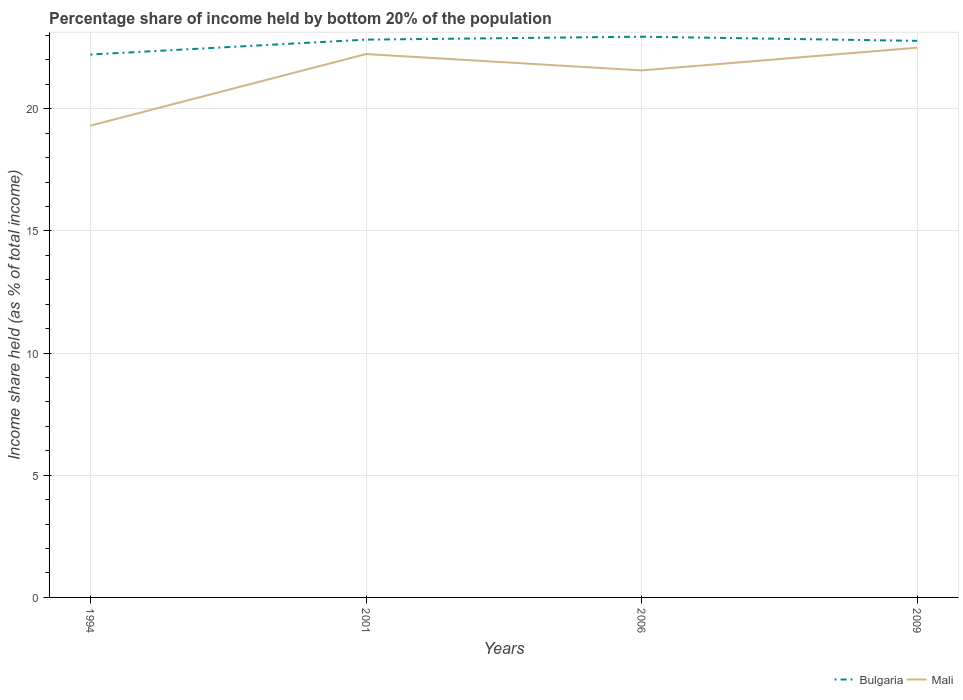How many different coloured lines are there?
Make the answer very short. 2. Does the line corresponding to Mali intersect with the line corresponding to Bulgaria?
Keep it short and to the point. No. Is the number of lines equal to the number of legend labels?
Provide a short and direct response. Yes. Across all years, what is the maximum share of income held by bottom 20% of the population in Bulgaria?
Your answer should be compact. 22.22. In which year was the share of income held by bottom 20% of the population in Bulgaria maximum?
Offer a very short reply. 1994. What is the total share of income held by bottom 20% of the population in Mali in the graph?
Your response must be concise. -3.19. What is the difference between the highest and the second highest share of income held by bottom 20% of the population in Mali?
Make the answer very short. 3.19. What is the difference between the highest and the lowest share of income held by bottom 20% of the population in Mali?
Keep it short and to the point. 3. Is the share of income held by bottom 20% of the population in Bulgaria strictly greater than the share of income held by bottom 20% of the population in Mali over the years?
Make the answer very short. No. How many lines are there?
Give a very brief answer. 2. Are the values on the major ticks of Y-axis written in scientific E-notation?
Offer a very short reply. No. Does the graph contain any zero values?
Your answer should be compact. No. Does the graph contain grids?
Offer a very short reply. Yes. How many legend labels are there?
Provide a succinct answer. 2. What is the title of the graph?
Make the answer very short. Percentage share of income held by bottom 20% of the population. What is the label or title of the X-axis?
Give a very brief answer. Years. What is the label or title of the Y-axis?
Your response must be concise. Income share held (as % of total income). What is the Income share held (as % of total income) of Bulgaria in 1994?
Your answer should be very brief. 22.22. What is the Income share held (as % of total income) in Mali in 1994?
Keep it short and to the point. 19.31. What is the Income share held (as % of total income) in Bulgaria in 2001?
Offer a very short reply. 22.83. What is the Income share held (as % of total income) of Mali in 2001?
Keep it short and to the point. 22.24. What is the Income share held (as % of total income) of Bulgaria in 2006?
Provide a short and direct response. 22.95. What is the Income share held (as % of total income) of Mali in 2006?
Offer a terse response. 21.57. What is the Income share held (as % of total income) of Bulgaria in 2009?
Give a very brief answer. 22.78. Across all years, what is the maximum Income share held (as % of total income) of Bulgaria?
Provide a succinct answer. 22.95. Across all years, what is the minimum Income share held (as % of total income) of Bulgaria?
Keep it short and to the point. 22.22. Across all years, what is the minimum Income share held (as % of total income) of Mali?
Give a very brief answer. 19.31. What is the total Income share held (as % of total income) of Bulgaria in the graph?
Ensure brevity in your answer.  90.78. What is the total Income share held (as % of total income) of Mali in the graph?
Your answer should be very brief. 85.62. What is the difference between the Income share held (as % of total income) in Bulgaria in 1994 and that in 2001?
Ensure brevity in your answer.  -0.61. What is the difference between the Income share held (as % of total income) of Mali in 1994 and that in 2001?
Your answer should be compact. -2.93. What is the difference between the Income share held (as % of total income) in Bulgaria in 1994 and that in 2006?
Offer a terse response. -0.73. What is the difference between the Income share held (as % of total income) of Mali in 1994 and that in 2006?
Your answer should be very brief. -2.26. What is the difference between the Income share held (as % of total income) of Bulgaria in 1994 and that in 2009?
Make the answer very short. -0.56. What is the difference between the Income share held (as % of total income) of Mali in 1994 and that in 2009?
Your answer should be compact. -3.19. What is the difference between the Income share held (as % of total income) in Bulgaria in 2001 and that in 2006?
Provide a short and direct response. -0.12. What is the difference between the Income share held (as % of total income) of Mali in 2001 and that in 2006?
Your answer should be compact. 0.67. What is the difference between the Income share held (as % of total income) of Mali in 2001 and that in 2009?
Your response must be concise. -0.26. What is the difference between the Income share held (as % of total income) in Bulgaria in 2006 and that in 2009?
Your response must be concise. 0.17. What is the difference between the Income share held (as % of total income) of Mali in 2006 and that in 2009?
Ensure brevity in your answer.  -0.93. What is the difference between the Income share held (as % of total income) in Bulgaria in 1994 and the Income share held (as % of total income) in Mali in 2001?
Provide a succinct answer. -0.02. What is the difference between the Income share held (as % of total income) of Bulgaria in 1994 and the Income share held (as % of total income) of Mali in 2006?
Give a very brief answer. 0.65. What is the difference between the Income share held (as % of total income) in Bulgaria in 1994 and the Income share held (as % of total income) in Mali in 2009?
Ensure brevity in your answer.  -0.28. What is the difference between the Income share held (as % of total income) of Bulgaria in 2001 and the Income share held (as % of total income) of Mali in 2006?
Provide a succinct answer. 1.26. What is the difference between the Income share held (as % of total income) in Bulgaria in 2001 and the Income share held (as % of total income) in Mali in 2009?
Offer a very short reply. 0.33. What is the difference between the Income share held (as % of total income) of Bulgaria in 2006 and the Income share held (as % of total income) of Mali in 2009?
Keep it short and to the point. 0.45. What is the average Income share held (as % of total income) of Bulgaria per year?
Give a very brief answer. 22.7. What is the average Income share held (as % of total income) in Mali per year?
Keep it short and to the point. 21.41. In the year 1994, what is the difference between the Income share held (as % of total income) of Bulgaria and Income share held (as % of total income) of Mali?
Your answer should be compact. 2.91. In the year 2001, what is the difference between the Income share held (as % of total income) of Bulgaria and Income share held (as % of total income) of Mali?
Your answer should be very brief. 0.59. In the year 2006, what is the difference between the Income share held (as % of total income) in Bulgaria and Income share held (as % of total income) in Mali?
Give a very brief answer. 1.38. In the year 2009, what is the difference between the Income share held (as % of total income) in Bulgaria and Income share held (as % of total income) in Mali?
Your response must be concise. 0.28. What is the ratio of the Income share held (as % of total income) of Bulgaria in 1994 to that in 2001?
Your answer should be compact. 0.97. What is the ratio of the Income share held (as % of total income) of Mali in 1994 to that in 2001?
Your answer should be very brief. 0.87. What is the ratio of the Income share held (as % of total income) of Bulgaria in 1994 to that in 2006?
Your response must be concise. 0.97. What is the ratio of the Income share held (as % of total income) of Mali in 1994 to that in 2006?
Your answer should be compact. 0.9. What is the ratio of the Income share held (as % of total income) in Bulgaria in 1994 to that in 2009?
Your answer should be very brief. 0.98. What is the ratio of the Income share held (as % of total income) of Mali in 1994 to that in 2009?
Offer a very short reply. 0.86. What is the ratio of the Income share held (as % of total income) of Mali in 2001 to that in 2006?
Offer a terse response. 1.03. What is the ratio of the Income share held (as % of total income) in Bulgaria in 2001 to that in 2009?
Offer a terse response. 1. What is the ratio of the Income share held (as % of total income) in Mali in 2001 to that in 2009?
Keep it short and to the point. 0.99. What is the ratio of the Income share held (as % of total income) of Bulgaria in 2006 to that in 2009?
Your answer should be compact. 1.01. What is the ratio of the Income share held (as % of total income) in Mali in 2006 to that in 2009?
Your answer should be very brief. 0.96. What is the difference between the highest and the second highest Income share held (as % of total income) in Bulgaria?
Your response must be concise. 0.12. What is the difference between the highest and the second highest Income share held (as % of total income) in Mali?
Make the answer very short. 0.26. What is the difference between the highest and the lowest Income share held (as % of total income) of Bulgaria?
Offer a terse response. 0.73. What is the difference between the highest and the lowest Income share held (as % of total income) of Mali?
Offer a terse response. 3.19. 